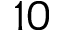<formula> <loc_0><loc_0><loc_500><loc_500>1 0</formula> 